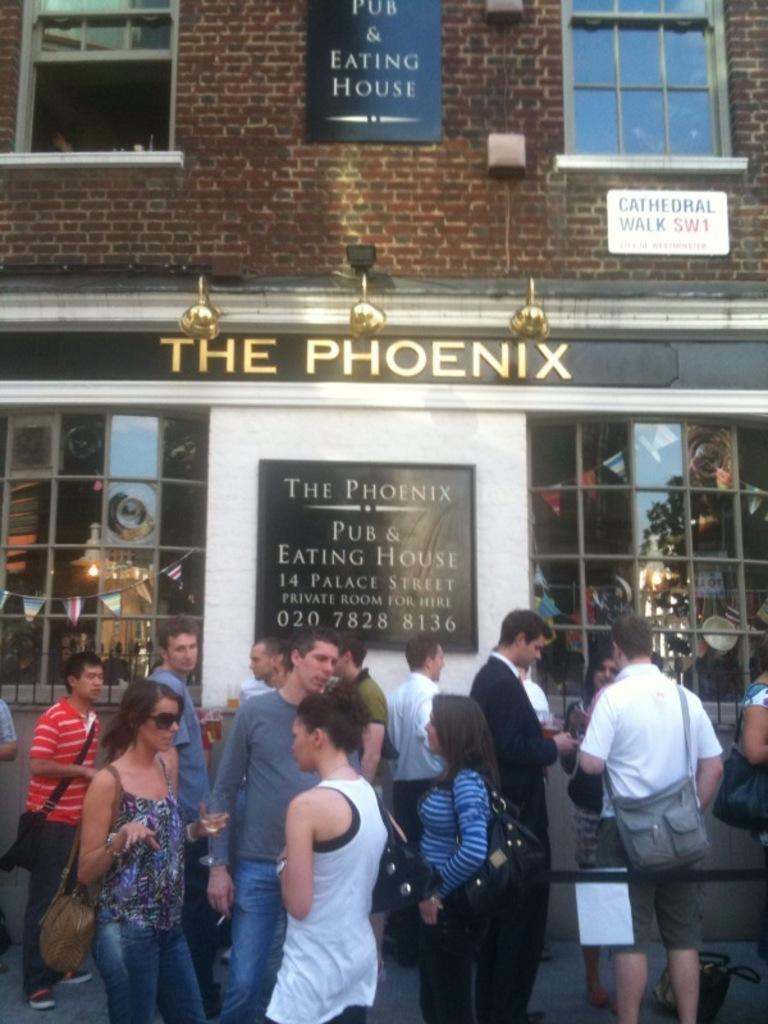What is happening on the road in the image? There is a group of people on the road in the image. What else can be seen on the road? There is an object on the road. What is located behind the people? There is a pub behind the people. Can you describe the lighting in the image? There is a light visible in the image. What type of architectural feature is present in the image? There are windows in the image. What is the board used for in the image? There is a board in the image, but its purpose is not clear from the facts provided. What type of brick is used to build the pot in the image? There is no pot or brick present in the image. How does the loss of the object affect the people in the image? There is no indication of any loss or its effect on the people in the image. 